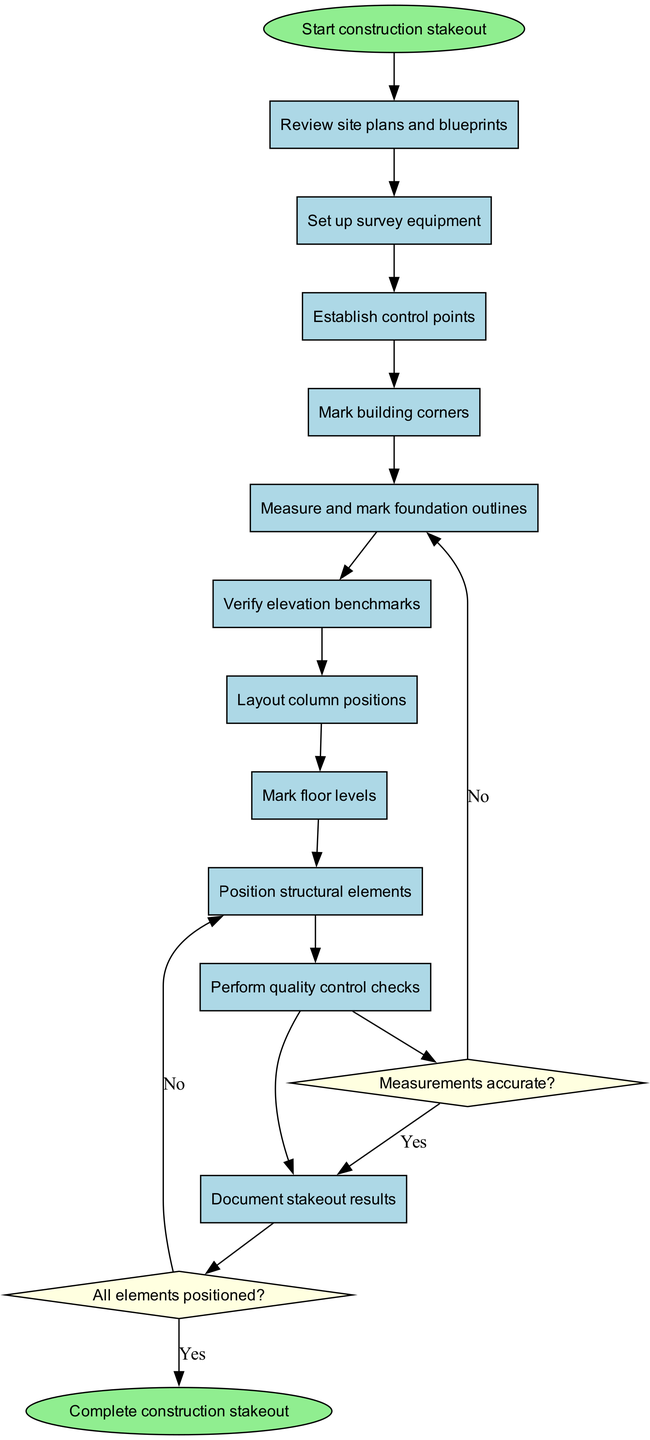What is the first activity in the diagram? The first activity is directly connected to the starting node. Following the flow from the start node, the first activity listed is "Review site plans and blueprints."
Answer: Review site plans and blueprints How many activities are present in the diagram? The diagram includes a list of activities, which can be counted by enumerating them in the provided data. There are 11 activities in total.
Answer: 11 Which node follows "Perform quality control checks"? From the diagram, "Perform quality control checks" leads to a decision node about measurement accuracy. This relationship can be traced directly through the flow connections.
Answer: Check measurements What decision leads to "Continue positioning"? The decision regarding whether all elements are positioned leads to "Continue positioning" if the answer is "No." This can be verified by tracing the connection from the decision node back to the appropriate activities.
Answer: All elements positioned? Which activity is positioned before "Document stakeout results"? The activity directly preceding "Document stakeout results" can be identified by following the flow from the preceding node in the activity list. The relevant activity is "Position structural elements."
Answer: Position structural elements What happens if measurements are deemed inaccurate? Following the diagram, if measurements are found to be inaccurate, the flow leads to "Recalibrate and remeasure." This connection is evident from the decision node regarding measurement accuracy.
Answer: Recalibrate and remeasure What signifies the completion of the stakeout process? The end of the process is represented by the final node in the diagram, which corresponds to the verification that all steps have been completed. This is explicitly stated as "Complete construction stakeout."
Answer: Complete construction stakeout Which activity confirms the positioning before documentation? Prior to documenting the stakeout results, the activity that confirms positioning is "Position structural elements." This is linked directly in the flow leading up to the documentation phase.
Answer: Position structural elements 